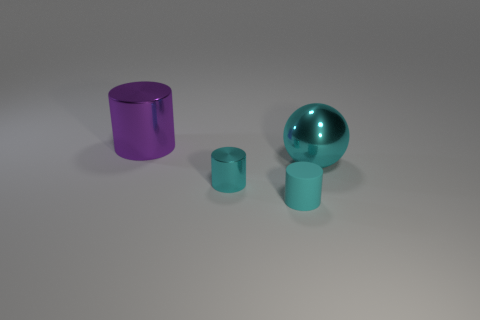Add 4 large cyan things. How many objects exist? 8 Subtract all cylinders. How many objects are left? 1 Subtract all big metal balls. Subtract all cyan metal spheres. How many objects are left? 2 Add 1 purple shiny things. How many purple shiny things are left? 2 Add 1 metal objects. How many metal objects exist? 4 Subtract 0 blue balls. How many objects are left? 4 